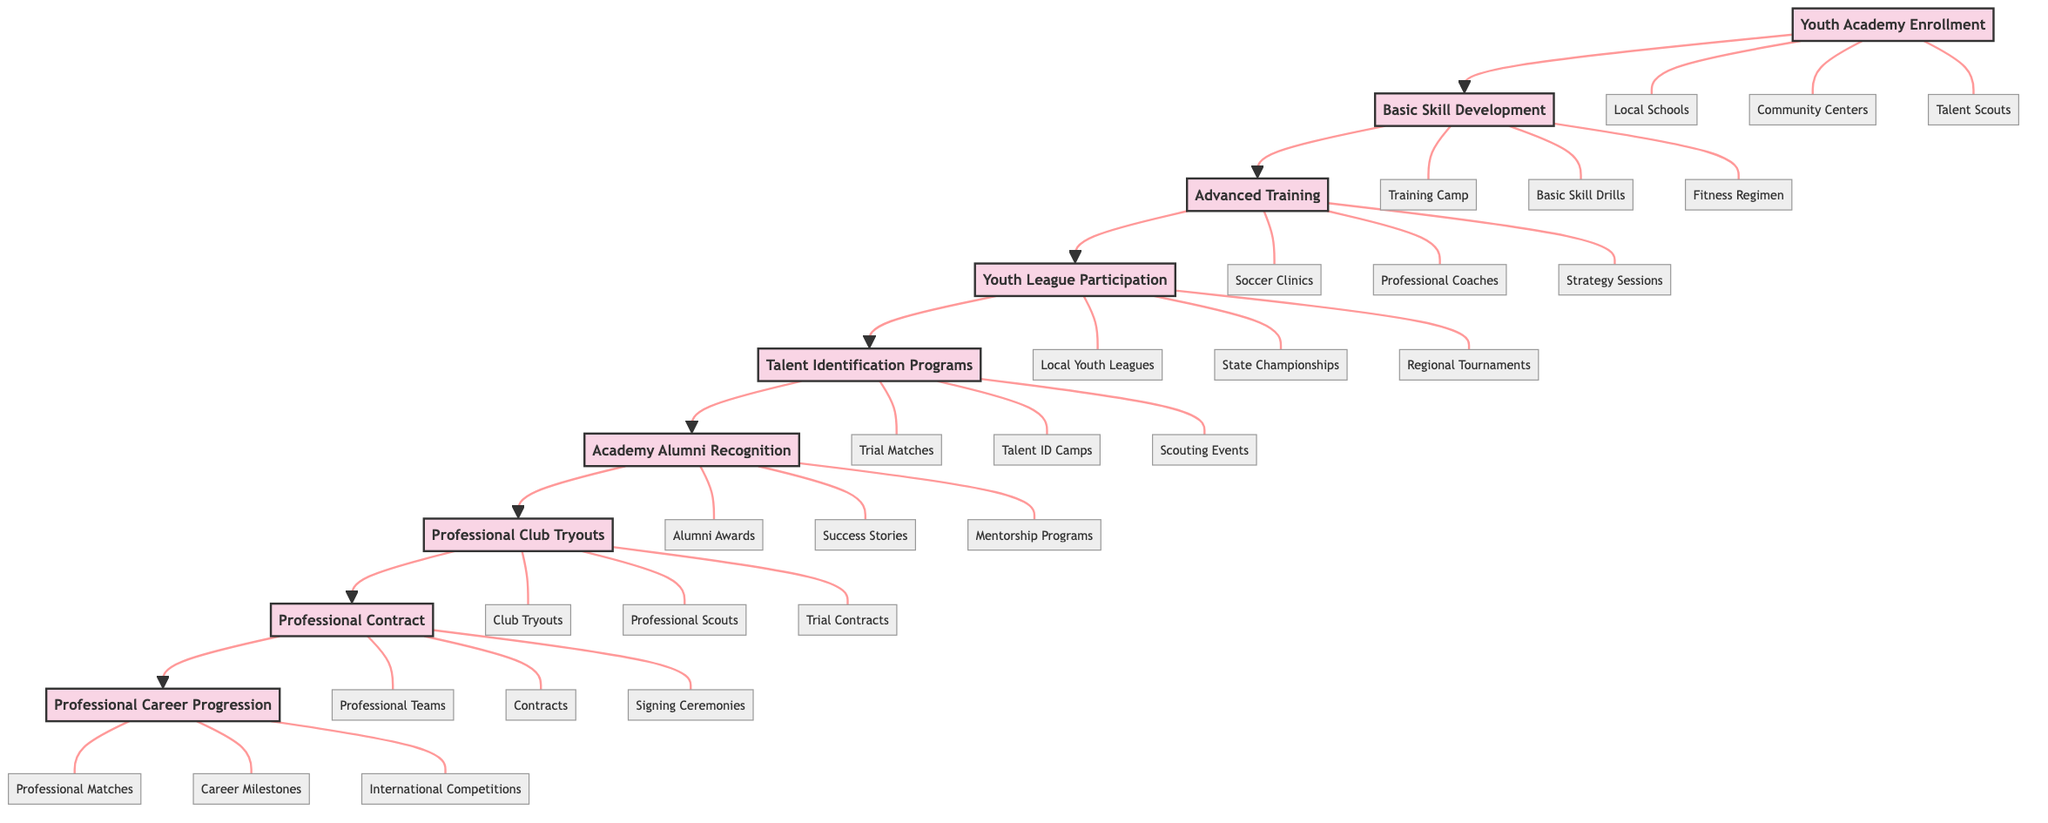What is the first stage of the alumni success progression? The first stage in the diagram is labeled "Youth Academy Enrollment." This is the starting point of the flow, indicating where alumni journey begins.
Answer: Youth Academy Enrollment How many stages are there in total in the progression? The diagram shows a total of nine stages, each representing a unique phase in the alumni's journey towards professional football.
Answer: Nine Which entities are associated with "Talent Identification Programs"? The diagram lists "Trial Matches," "Talent ID Camps," and "Scouting Events" as the entities related to the "Talent Identification Programs" stage. These entities signify avenues through which players' talents are showcased.
Answer: Trial Matches, Talent ID Camps, Scouting Events What is the last stage of the progression? The last stage shown in the flowchart is "Professional Career Progression," which represents the culmination of a player’s journey after signing a professional contract.
Answer: Professional Career Progression Describe the relationship between "Professional Contract" and "Professional Club Tryouts." "Professional Contract" follows directly after "Professional Club Tryouts" in the diagram. This indicates that securing a professional contract is contingent upon successfully completing tryouts at professional clubs.
Answer: Professional Contract follows Professional Club Tryouts Which stage has the associated entities of "Alumni Awards," "Success Stories," and "Mentorship Programs"? These entities are linked to the "Academy Alumni Recognition" stage, showing that this phase focuses on celebrating and recognizing notable alumni and their achievements.
Answer: Academy Alumni Recognition What comes immediately before "Professional Contract"? "Professional Club Tryouts" is the stage that immediately precedes "Professional Contract." This suggests that players must first go through tryouts to earn contracts with professional teams.
Answer: Professional Club Tryouts Identify the stage where players first begin competing. Players begin competing in "Youth League Participation," which is where they are involved in organized matches to gain experience in real competitive environments.
Answer: Youth League Participation How does the diagram structure flow from bottom to top? The diagram is structured in a linear flow, starting from the foundational stage at the bottom ("Youth Academy Enrollment") and culminating at the top with "Professional Career Progression," indicating a progression of steps that must be passed sequentially.
Answer: Linear progression from bottom to top 